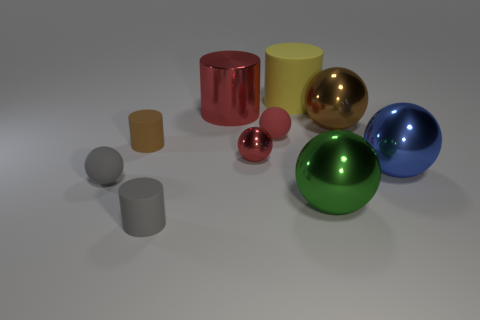Is there a small metallic ball that has the same color as the large metal cylinder?
Offer a very short reply. Yes. Is the color of the big shiny thing that is to the left of the green ball the same as the tiny shiny object?
Ensure brevity in your answer.  Yes. What number of objects are large metal objects in front of the red cylinder or red shiny objects?
Your answer should be very brief. 5. Are there more large metal spheres that are in front of the tiny red shiny object than metal cylinders to the right of the green metallic object?
Provide a short and direct response. Yes. Are the big blue ball and the large red cylinder made of the same material?
Ensure brevity in your answer.  Yes. What is the shape of the large metallic thing that is behind the blue thing and in front of the large red metallic cylinder?
Your response must be concise. Sphere. There is another small object that is made of the same material as the blue object; what shape is it?
Make the answer very short. Sphere. Are any small purple things visible?
Provide a short and direct response. No. There is a gray thing behind the green sphere; is there a big brown ball on the right side of it?
Offer a terse response. Yes. What material is the tiny gray thing that is the same shape as the big red metal thing?
Provide a succinct answer. Rubber. 